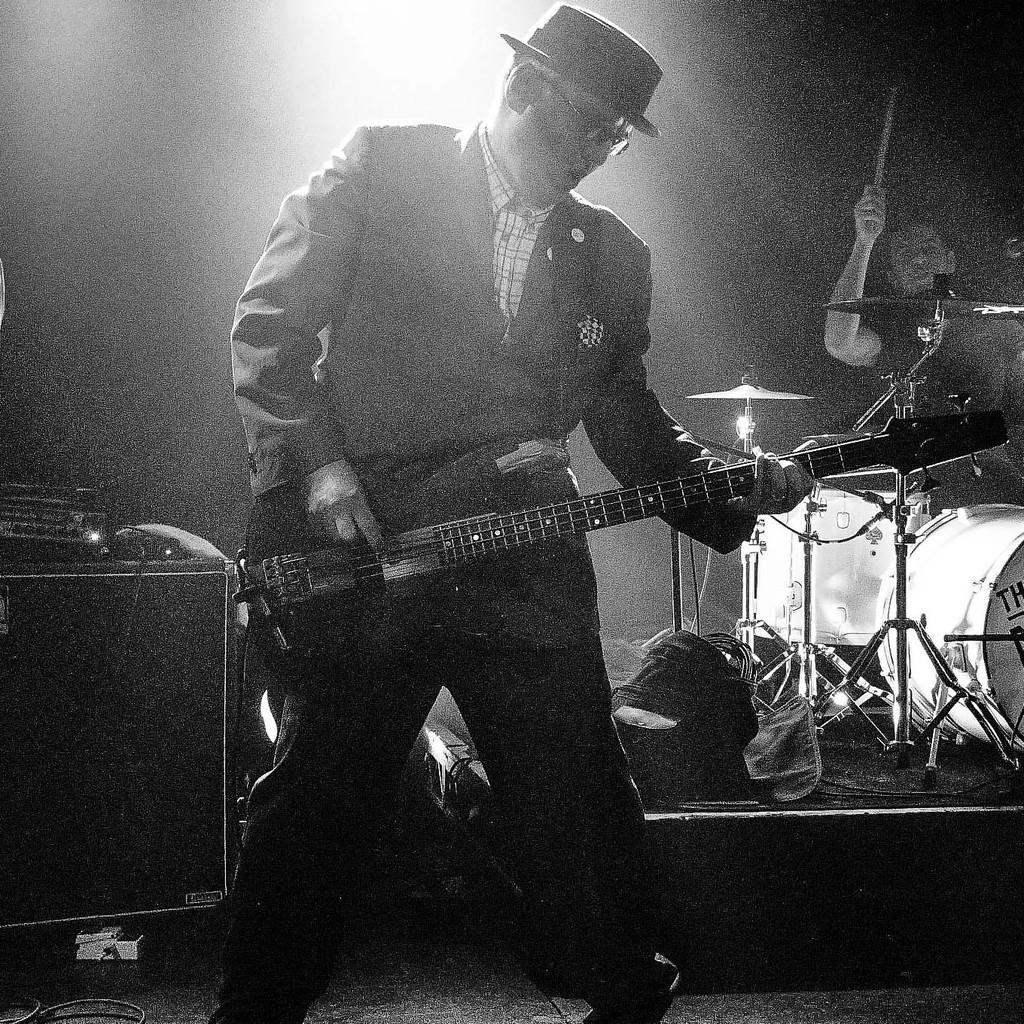Could you give a brief overview of what you see in this image? In this picture we can see a man standing and playing a guitar, he wore a cap, in the background there are two drums and cymbals, we can see a person here, there is a stick in his hand. 